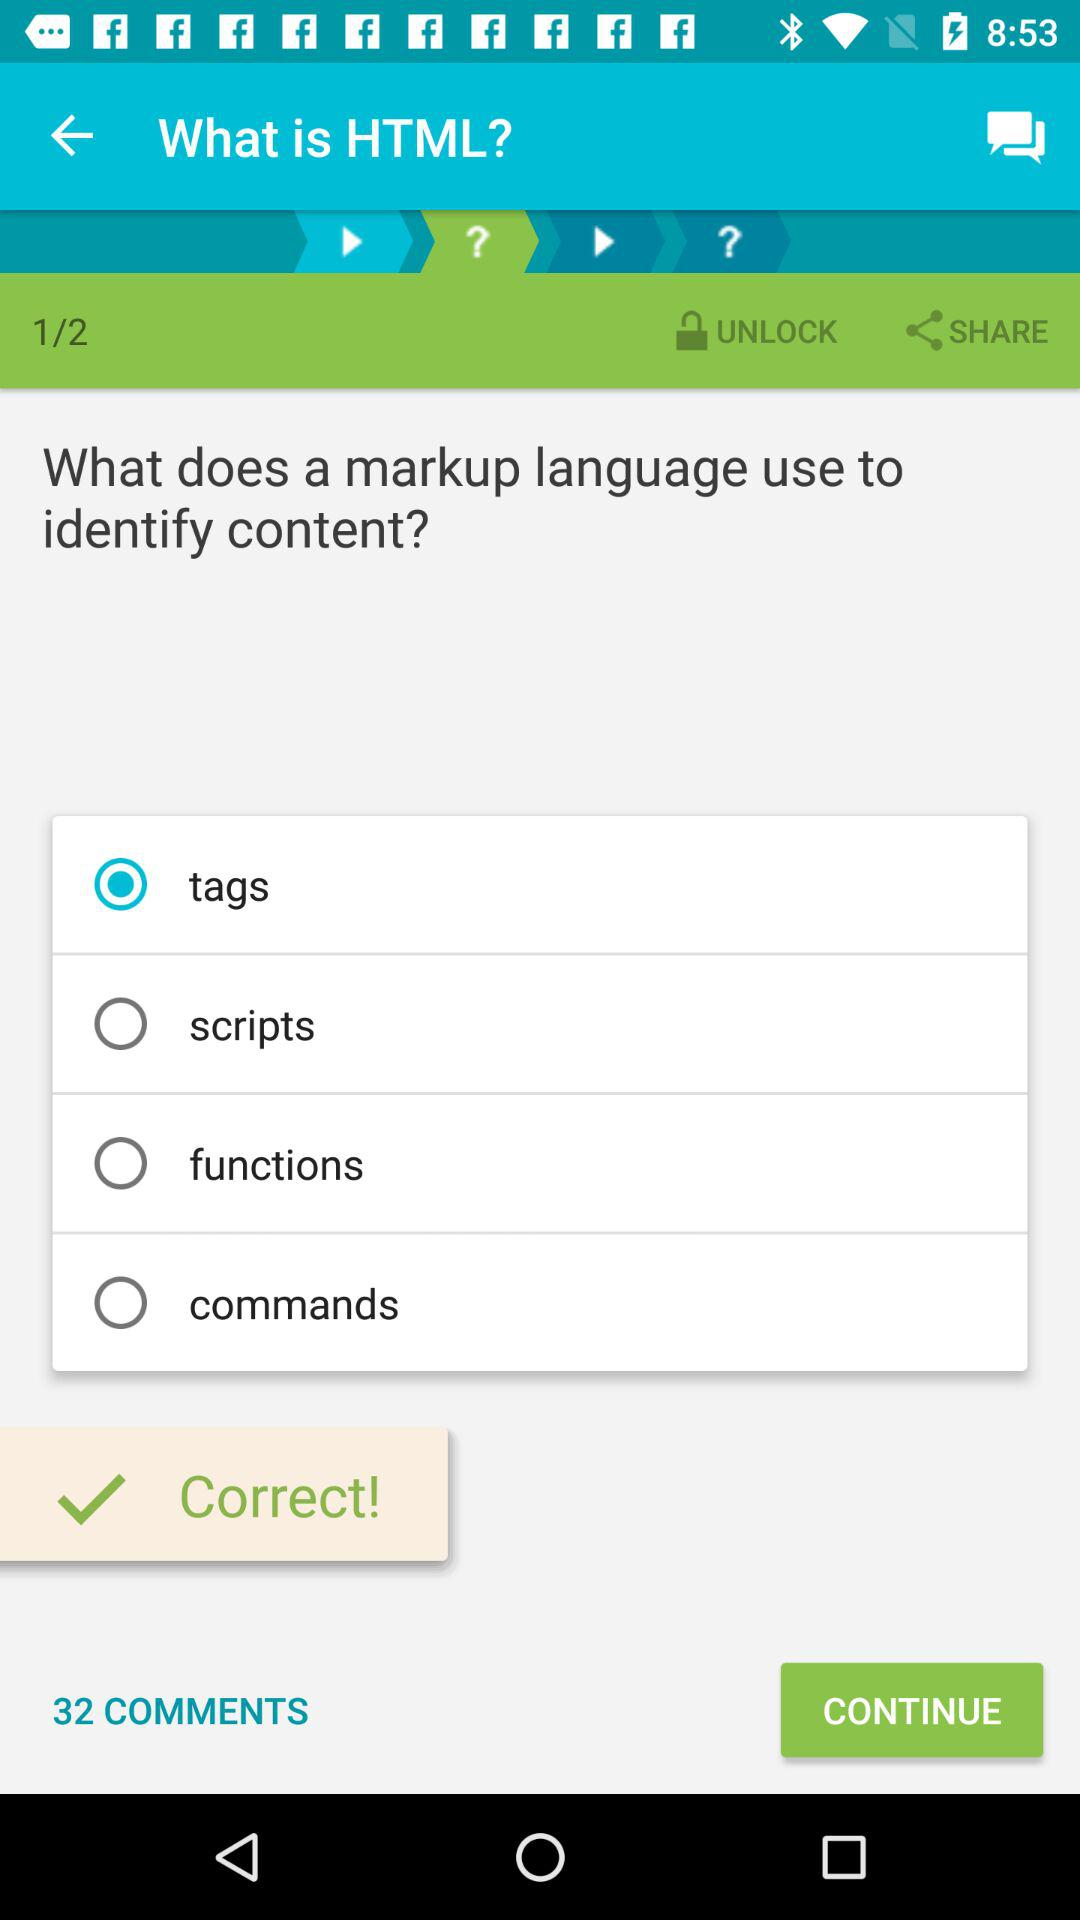Which option is selected? The selected option is "tags". 